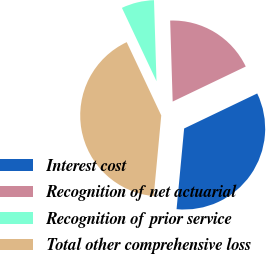<chart> <loc_0><loc_0><loc_500><loc_500><pie_chart><fcel>Interest cost<fcel>Recognition of net actuarial<fcel>Recognition of prior service<fcel>Total other comprehensive loss<nl><fcel>33.6%<fcel>18.38%<fcel>6.52%<fcel>41.5%<nl></chart> 